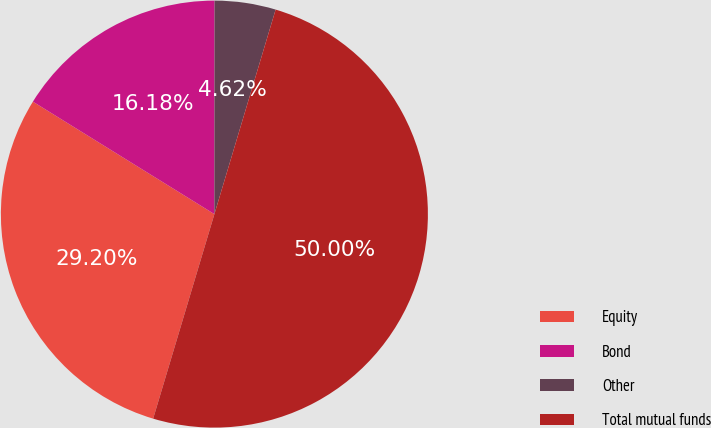<chart> <loc_0><loc_0><loc_500><loc_500><pie_chart><fcel>Equity<fcel>Bond<fcel>Other<fcel>Total mutual funds<nl><fcel>29.2%<fcel>16.18%<fcel>4.62%<fcel>50.0%<nl></chart> 